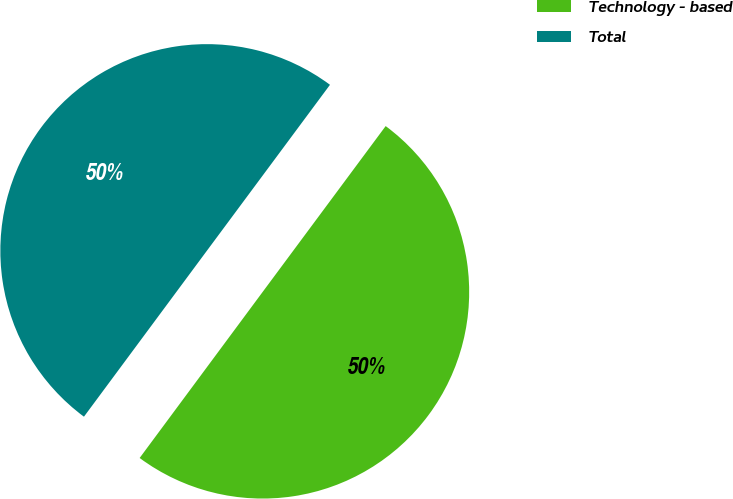Convert chart to OTSL. <chart><loc_0><loc_0><loc_500><loc_500><pie_chart><fcel>Technology - based<fcel>Total<nl><fcel>49.99%<fcel>50.01%<nl></chart> 